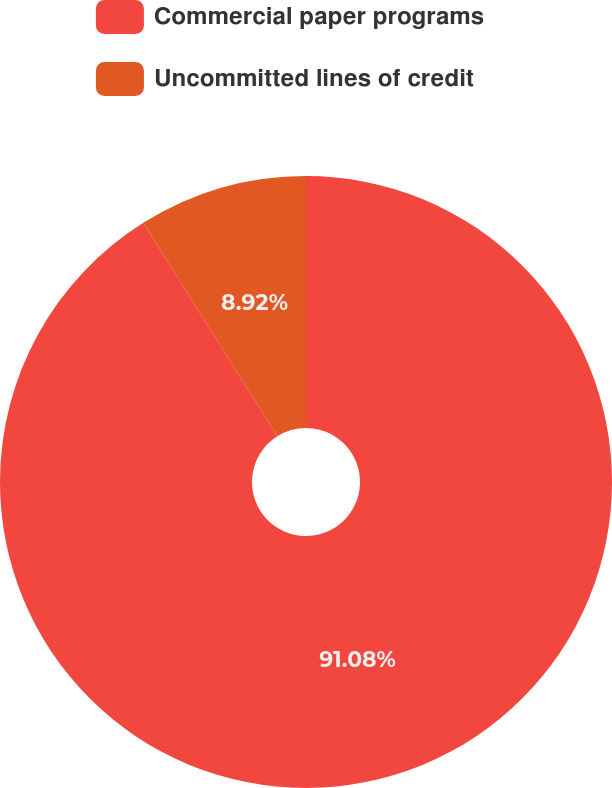Convert chart. <chart><loc_0><loc_0><loc_500><loc_500><pie_chart><fcel>Commercial paper programs<fcel>Uncommitted lines of credit<nl><fcel>91.08%<fcel>8.92%<nl></chart> 